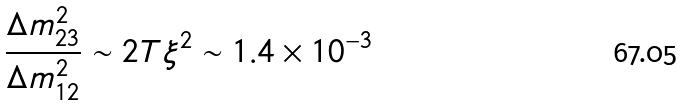<formula> <loc_0><loc_0><loc_500><loc_500>\frac { \Delta m _ { 2 3 } ^ { 2 } } { \Delta m _ { 1 2 } ^ { 2 } } \sim 2 T \xi ^ { 2 } \sim 1 . 4 \times 1 0 ^ { - 3 }</formula> 